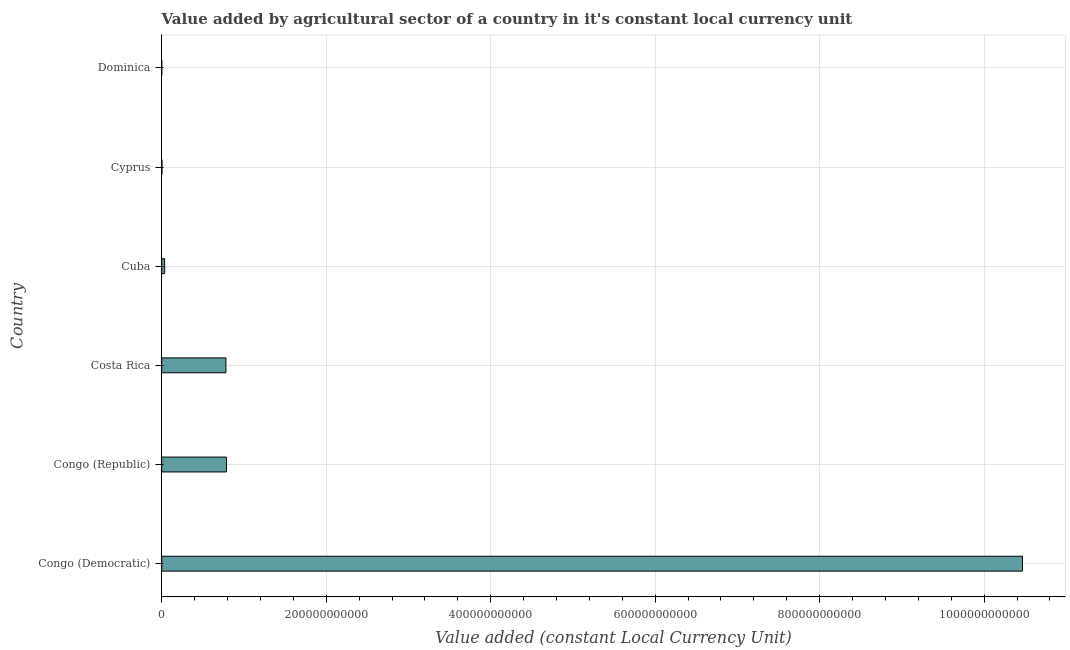Does the graph contain any zero values?
Offer a terse response. No. What is the title of the graph?
Give a very brief answer. Value added by agricultural sector of a country in it's constant local currency unit. What is the label or title of the X-axis?
Provide a short and direct response. Value added (constant Local Currency Unit). What is the value added by agriculture sector in Cuba?
Give a very brief answer. 3.58e+09. Across all countries, what is the maximum value added by agriculture sector?
Provide a short and direct response. 1.05e+12. Across all countries, what is the minimum value added by agriculture sector?
Your answer should be very brief. 1.13e+08. In which country was the value added by agriculture sector maximum?
Ensure brevity in your answer.  Congo (Democratic). In which country was the value added by agriculture sector minimum?
Offer a terse response. Dominica. What is the sum of the value added by agriculture sector?
Your answer should be compact. 1.21e+12. What is the difference between the value added by agriculture sector in Costa Rica and Cuba?
Provide a short and direct response. 7.45e+1. What is the average value added by agriculture sector per country?
Provide a short and direct response. 2.01e+11. What is the median value added by agriculture sector?
Provide a short and direct response. 4.08e+1. What is the ratio of the value added by agriculture sector in Costa Rica to that in Dominica?
Your answer should be very brief. 689.7. What is the difference between the highest and the second highest value added by agriculture sector?
Make the answer very short. 9.68e+11. Is the sum of the value added by agriculture sector in Costa Rica and Cyprus greater than the maximum value added by agriculture sector across all countries?
Ensure brevity in your answer.  No. What is the difference between the highest and the lowest value added by agriculture sector?
Make the answer very short. 1.05e+12. In how many countries, is the value added by agriculture sector greater than the average value added by agriculture sector taken over all countries?
Offer a very short reply. 1. How many bars are there?
Your answer should be very brief. 6. What is the difference between two consecutive major ticks on the X-axis?
Make the answer very short. 2.00e+11. Are the values on the major ticks of X-axis written in scientific E-notation?
Your answer should be compact. No. What is the Value added (constant Local Currency Unit) of Congo (Democratic)?
Your answer should be compact. 1.05e+12. What is the Value added (constant Local Currency Unit) of Congo (Republic)?
Offer a very short reply. 7.87e+1. What is the Value added (constant Local Currency Unit) in Costa Rica?
Your answer should be compact. 7.81e+1. What is the Value added (constant Local Currency Unit) in Cuba?
Make the answer very short. 3.58e+09. What is the Value added (constant Local Currency Unit) of Cyprus?
Your answer should be compact. 2.82e+08. What is the Value added (constant Local Currency Unit) in Dominica?
Keep it short and to the point. 1.13e+08. What is the difference between the Value added (constant Local Currency Unit) in Congo (Democratic) and Congo (Republic)?
Your answer should be very brief. 9.68e+11. What is the difference between the Value added (constant Local Currency Unit) in Congo (Democratic) and Costa Rica?
Offer a terse response. 9.68e+11. What is the difference between the Value added (constant Local Currency Unit) in Congo (Democratic) and Cuba?
Ensure brevity in your answer.  1.04e+12. What is the difference between the Value added (constant Local Currency Unit) in Congo (Democratic) and Cyprus?
Your answer should be very brief. 1.05e+12. What is the difference between the Value added (constant Local Currency Unit) in Congo (Democratic) and Dominica?
Provide a succinct answer. 1.05e+12. What is the difference between the Value added (constant Local Currency Unit) in Congo (Republic) and Costa Rica?
Your response must be concise. 6.85e+08. What is the difference between the Value added (constant Local Currency Unit) in Congo (Republic) and Cuba?
Keep it short and to the point. 7.52e+1. What is the difference between the Value added (constant Local Currency Unit) in Congo (Republic) and Cyprus?
Your response must be concise. 7.85e+1. What is the difference between the Value added (constant Local Currency Unit) in Congo (Republic) and Dominica?
Provide a succinct answer. 7.86e+1. What is the difference between the Value added (constant Local Currency Unit) in Costa Rica and Cuba?
Ensure brevity in your answer.  7.45e+1. What is the difference between the Value added (constant Local Currency Unit) in Costa Rica and Cyprus?
Provide a succinct answer. 7.78e+1. What is the difference between the Value added (constant Local Currency Unit) in Costa Rica and Dominica?
Offer a terse response. 7.79e+1. What is the difference between the Value added (constant Local Currency Unit) in Cuba and Cyprus?
Keep it short and to the point. 3.29e+09. What is the difference between the Value added (constant Local Currency Unit) in Cuba and Dominica?
Your response must be concise. 3.46e+09. What is the difference between the Value added (constant Local Currency Unit) in Cyprus and Dominica?
Provide a short and direct response. 1.69e+08. What is the ratio of the Value added (constant Local Currency Unit) in Congo (Democratic) to that in Congo (Republic)?
Your response must be concise. 13.29. What is the ratio of the Value added (constant Local Currency Unit) in Congo (Democratic) to that in Costa Rica?
Offer a very short reply. 13.41. What is the ratio of the Value added (constant Local Currency Unit) in Congo (Democratic) to that in Cuba?
Keep it short and to the point. 292.67. What is the ratio of the Value added (constant Local Currency Unit) in Congo (Democratic) to that in Cyprus?
Offer a very short reply. 3709.91. What is the ratio of the Value added (constant Local Currency Unit) in Congo (Democratic) to that in Dominica?
Keep it short and to the point. 9247.04. What is the ratio of the Value added (constant Local Currency Unit) in Congo (Republic) to that in Cuba?
Your answer should be compact. 22.02. What is the ratio of the Value added (constant Local Currency Unit) in Congo (Republic) to that in Cyprus?
Offer a very short reply. 279.14. What is the ratio of the Value added (constant Local Currency Unit) in Congo (Republic) to that in Dominica?
Keep it short and to the point. 695.76. What is the ratio of the Value added (constant Local Currency Unit) in Costa Rica to that in Cuba?
Give a very brief answer. 21.83. What is the ratio of the Value added (constant Local Currency Unit) in Costa Rica to that in Cyprus?
Give a very brief answer. 276.71. What is the ratio of the Value added (constant Local Currency Unit) in Costa Rica to that in Dominica?
Your answer should be compact. 689.7. What is the ratio of the Value added (constant Local Currency Unit) in Cuba to that in Cyprus?
Offer a very short reply. 12.68. What is the ratio of the Value added (constant Local Currency Unit) in Cuba to that in Dominica?
Offer a terse response. 31.59. What is the ratio of the Value added (constant Local Currency Unit) in Cyprus to that in Dominica?
Provide a succinct answer. 2.49. 